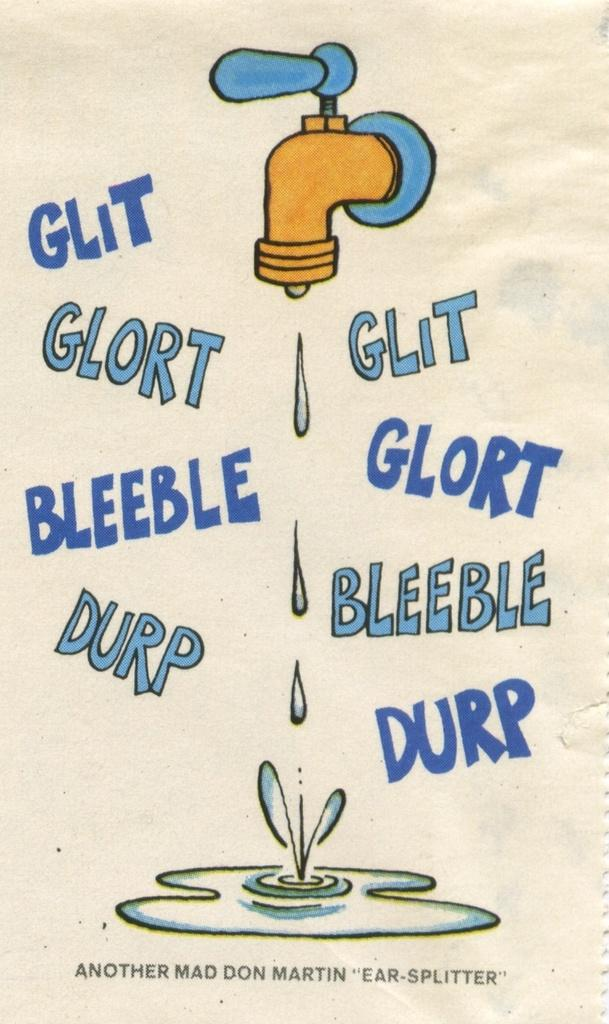<image>
Write a terse but informative summary of the picture. A poster of a dripping water faucet has the words glit, glort, bleeble, and durp on it. 